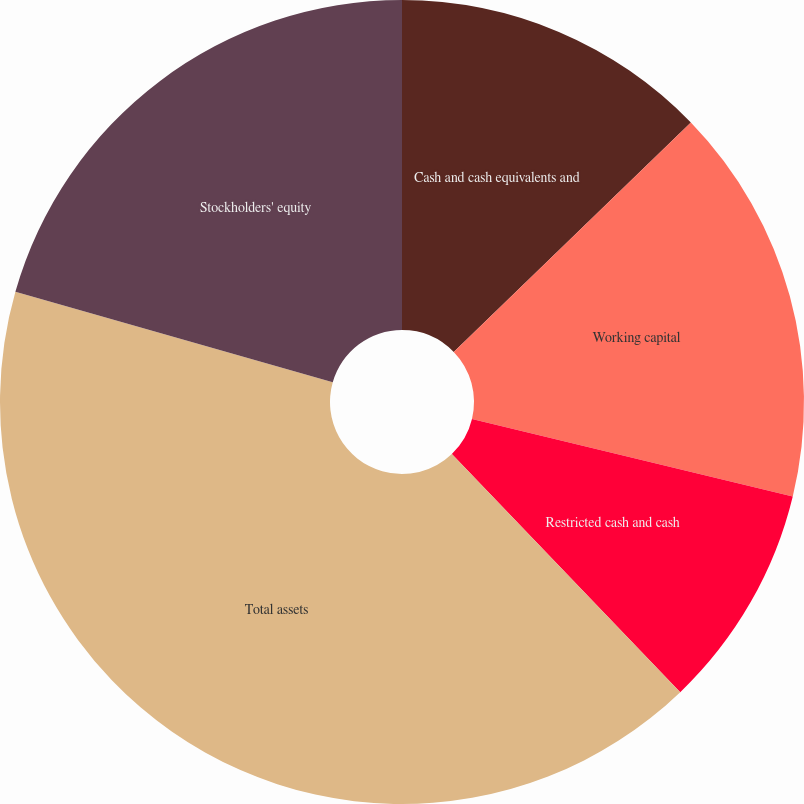<chart> <loc_0><loc_0><loc_500><loc_500><pie_chart><fcel>Cash and cash equivalents and<fcel>Working capital<fcel>Restricted cash and cash<fcel>Total assets<fcel>Stockholders' equity<nl><fcel>12.76%<fcel>16.01%<fcel>9.06%<fcel>41.58%<fcel>20.58%<nl></chart> 